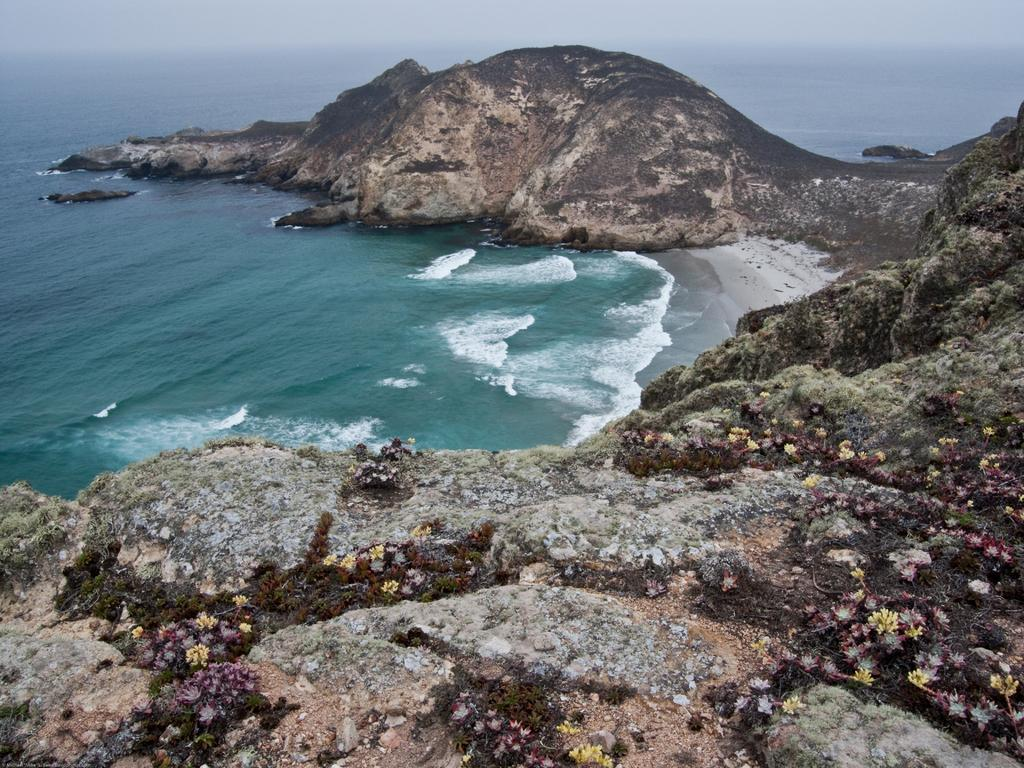What type of natural body of water is present in the image? There is a sea in the image. What geological feature surrounds the sea in the image? There is a huge rock hill around the sea in the image. Can you see the lip of the grandmother in the image? There is no lip or grandmother present in the image. What type of agricultural structure can be seen near the sea in the image? There is no agricultural structure, such as a scarecrow, present in the image. 